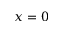Convert formula to latex. <formula><loc_0><loc_0><loc_500><loc_500>x = 0</formula> 